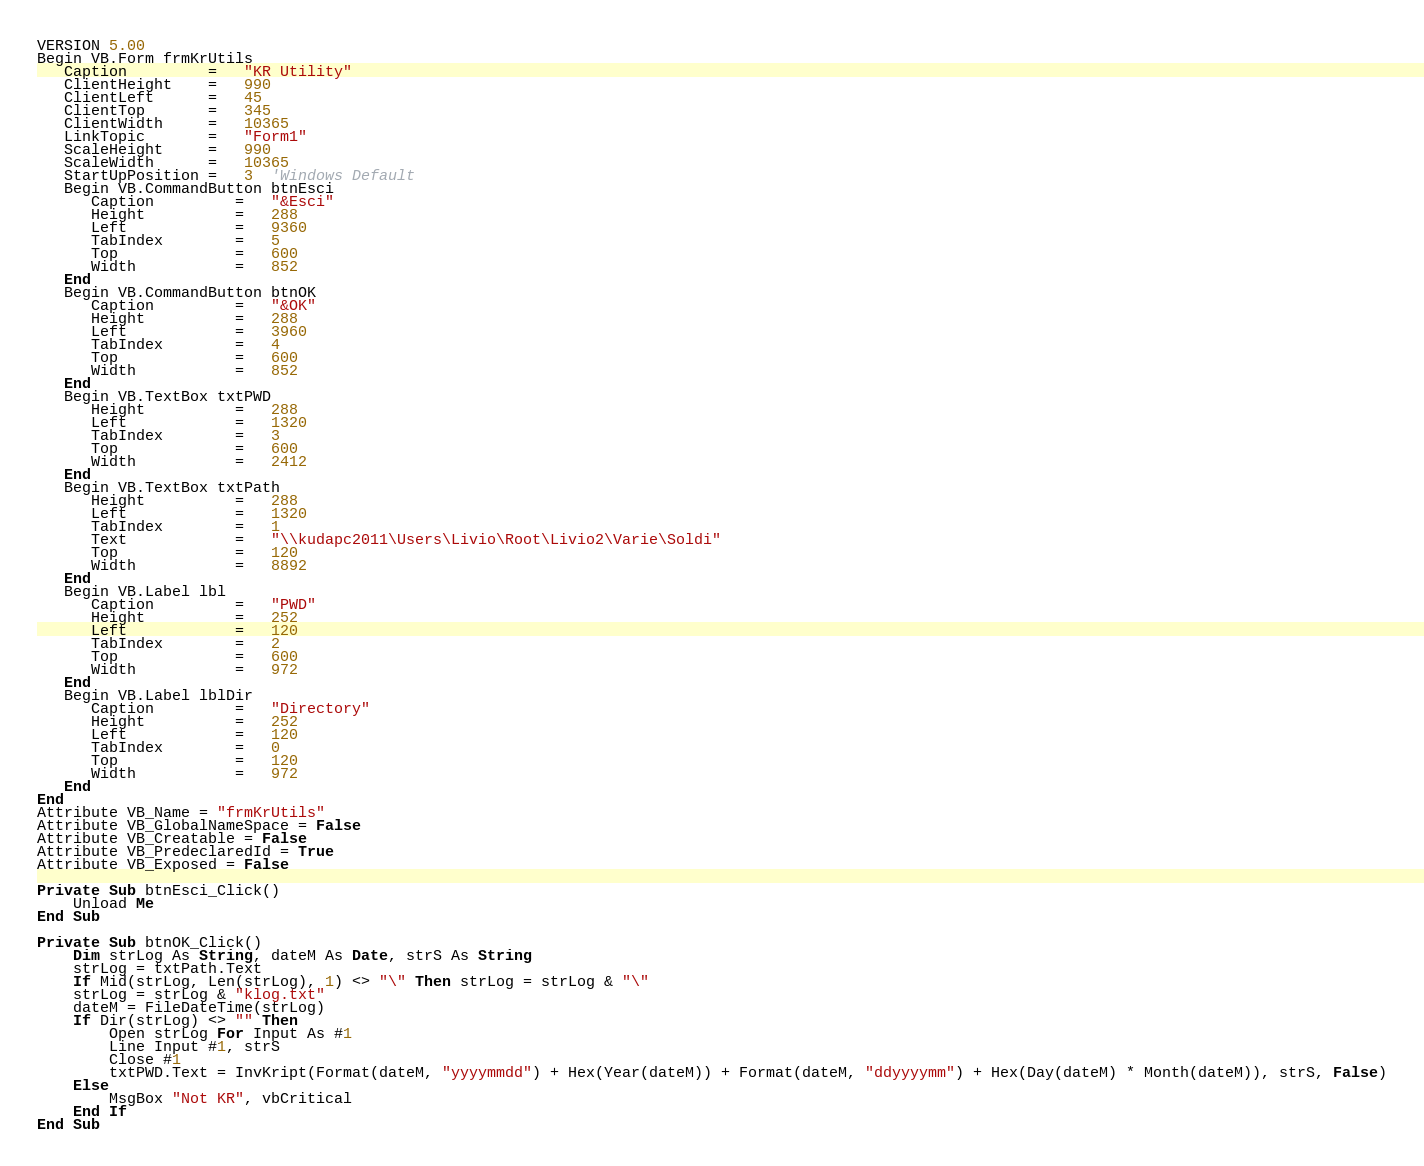<code> <loc_0><loc_0><loc_500><loc_500><_VisualBasic_>VERSION 5.00
Begin VB.Form frmKrUtils 
   Caption         =   "KR Utility"
   ClientHeight    =   990
   ClientLeft      =   45
   ClientTop       =   345
   ClientWidth     =   10365
   LinkTopic       =   "Form1"
   ScaleHeight     =   990
   ScaleWidth      =   10365
   StartUpPosition =   3  'Windows Default
   Begin VB.CommandButton btnEsci 
      Caption         =   "&Esci"
      Height          =   288
      Left            =   9360
      TabIndex        =   5
      Top             =   600
      Width           =   852
   End
   Begin VB.CommandButton btnOK 
      Caption         =   "&OK"
      Height          =   288
      Left            =   3960
      TabIndex        =   4
      Top             =   600
      Width           =   852
   End
   Begin VB.TextBox txtPWD 
      Height          =   288
      Left            =   1320
      TabIndex        =   3
      Top             =   600
      Width           =   2412
   End
   Begin VB.TextBox txtPath 
      Height          =   288
      Left            =   1320
      TabIndex        =   1
      Text            =   "\\kudapc2011\Users\Livio\Root\Livio2\Varie\Soldi"
      Top             =   120
      Width           =   8892
   End
   Begin VB.Label lbl 
      Caption         =   "PWD"
      Height          =   252
      Left            =   120
      TabIndex        =   2
      Top             =   600
      Width           =   972
   End
   Begin VB.Label lblDir 
      Caption         =   "Directory"
      Height          =   252
      Left            =   120
      TabIndex        =   0
      Top             =   120
      Width           =   972
   End
End
Attribute VB_Name = "frmKrUtils"
Attribute VB_GlobalNameSpace = False
Attribute VB_Creatable = False
Attribute VB_PredeclaredId = True
Attribute VB_Exposed = False

Private Sub btnEsci_Click()
    Unload Me
End Sub

Private Sub btnOK_Click()
    Dim strLog As String, dateM As Date, strS As String
    strLog = txtPath.Text
    If Mid(strLog, Len(strLog), 1) <> "\" Then strLog = strLog & "\"
    strLog = strLog & "klog.txt"
    dateM = FileDateTime(strLog)
    If Dir(strLog) <> "" Then
        Open strLog For Input As #1
        Line Input #1, strS
        Close #1
        txtPWD.Text = InvKript(Format(dateM, "yyyymmdd") + Hex(Year(dateM)) + Format(dateM, "ddyyyymm") + Hex(Day(dateM) * Month(dateM)), strS, False)
    Else
        MsgBox "Not KR", vbCritical
    End If
End Sub
</code> 